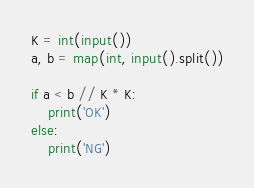<code> <loc_0><loc_0><loc_500><loc_500><_Python_>K = int(input())
a, b = map(int, input().split())

if a < b // K * K:
    print('OK')
else:
    print('NG')</code> 